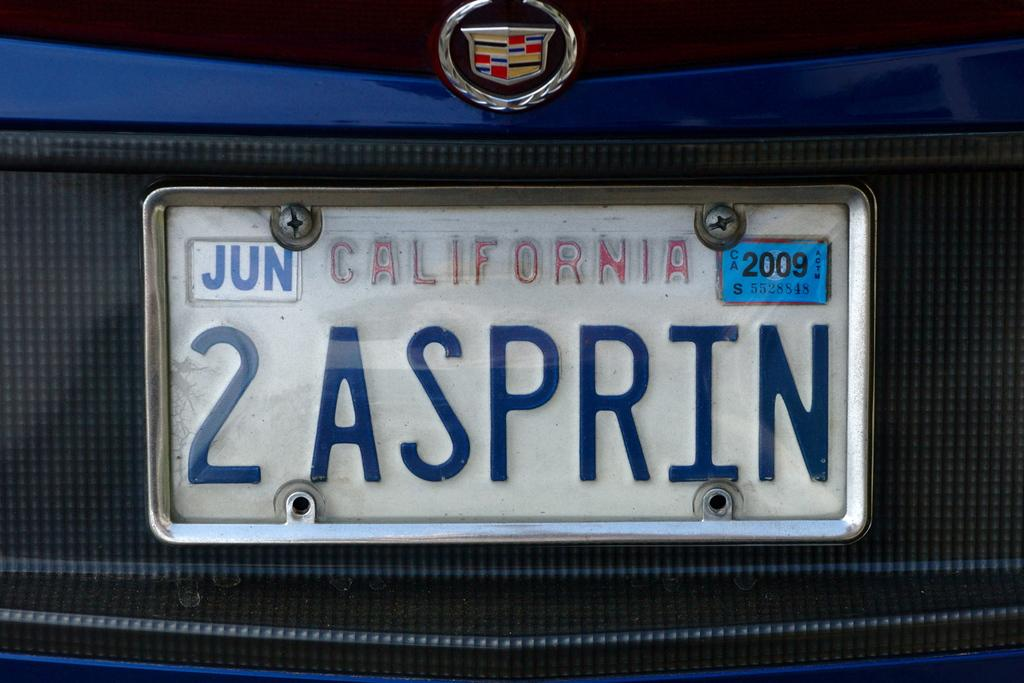<image>
Provide a brief description of the given image. A close up the licence plate of a blue and gray car registered in California. 